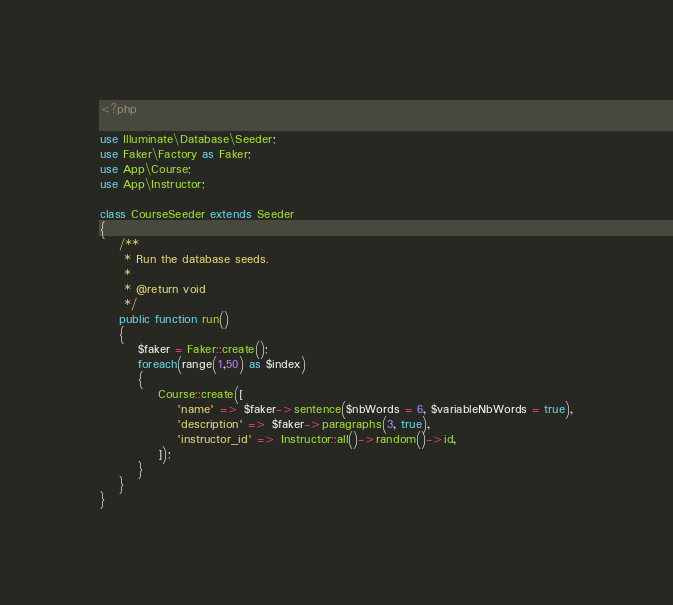Convert code to text. <code><loc_0><loc_0><loc_500><loc_500><_PHP_><?php

use Illuminate\Database\Seeder;
use Faker\Factory as Faker;
use App\Course;
use App\Instructor;

class CourseSeeder extends Seeder
{
    /**
     * Run the database seeds.
     *
     * @return void
     */
    public function run()
    {
        $faker = Faker::create();
        foreach(range(1,50) as $index)
        {
        	Course::create([
        		'name' => $faker->sentence($nbWords = 6, $variableNbWords = true),
        		'description' => $faker->paragraphs(3, true),
        		'instructor_id' => Instructor::all()->random()->id,
        	]);
        }
    }
}
</code> 